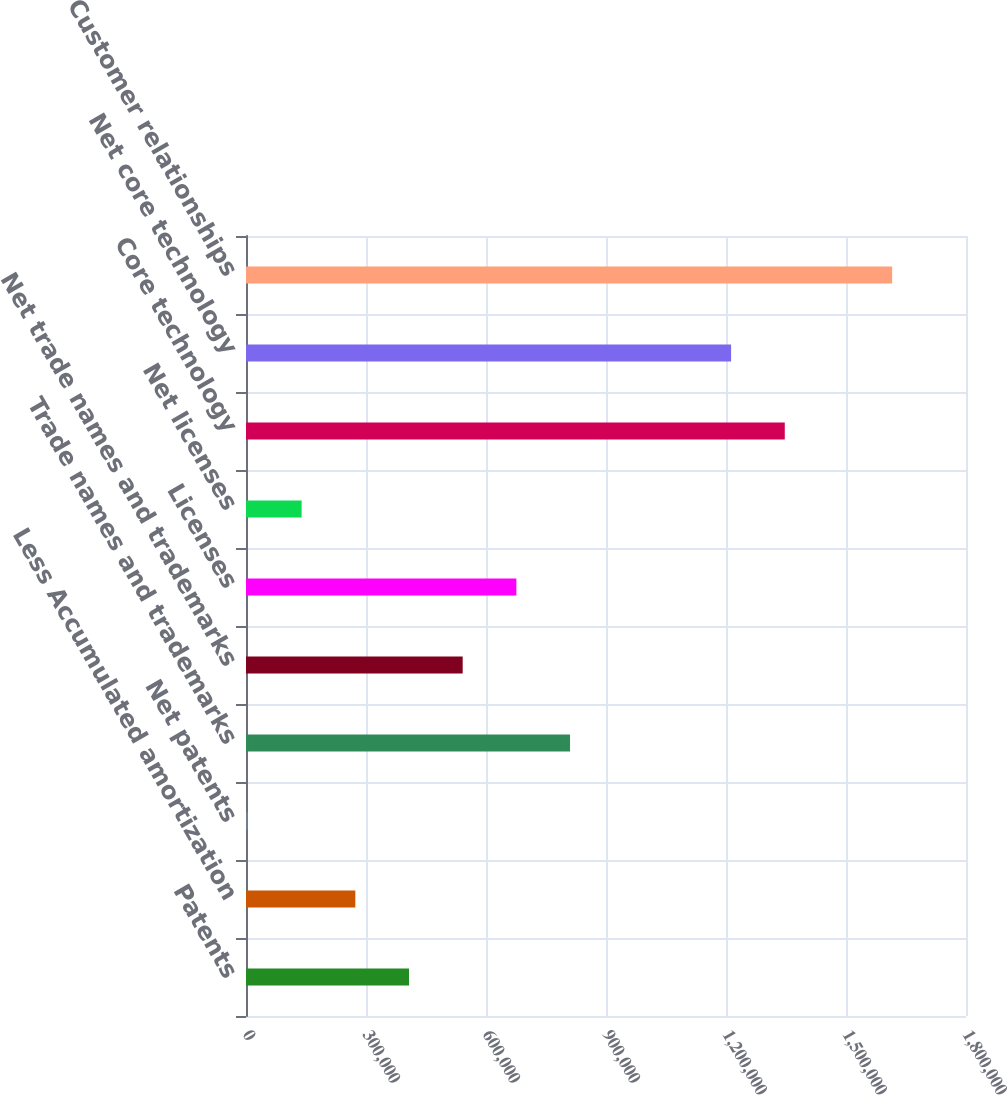<chart> <loc_0><loc_0><loc_500><loc_500><bar_chart><fcel>Patents<fcel>Less Accumulated amortization<fcel>Net patents<fcel>Trade names and trademarks<fcel>Net trade names and trademarks<fcel>Licenses<fcel>Net licenses<fcel>Core technology<fcel>Net core technology<fcel>Customer relationships<nl><fcel>407494<fcel>273287<fcel>4874<fcel>810114<fcel>541700<fcel>675907<fcel>139081<fcel>1.34694e+06<fcel>1.21273e+06<fcel>1.61535e+06<nl></chart> 